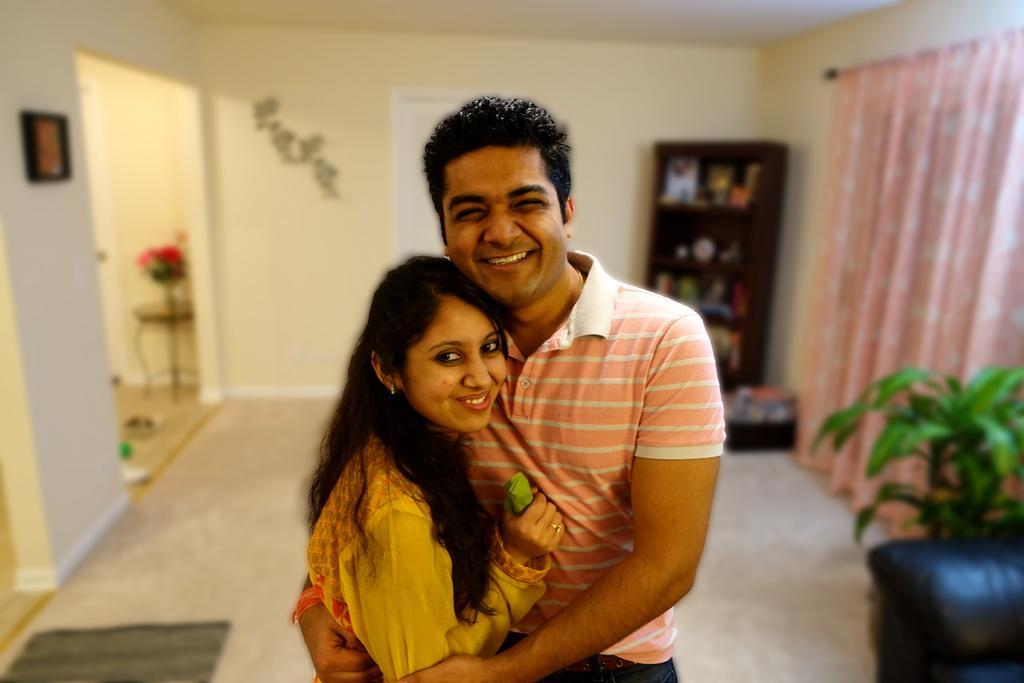Please provide a concise description of this image. This picture consists of two persons visible in the foreground and they are smiling and background I can see the wall, in front of the wall there is a cupboard, on the right side there is a curtain and plant and sofa chair, on left side there is a table and flower vase and photo frame attached to the wall and a carpet visible at the bottom. 